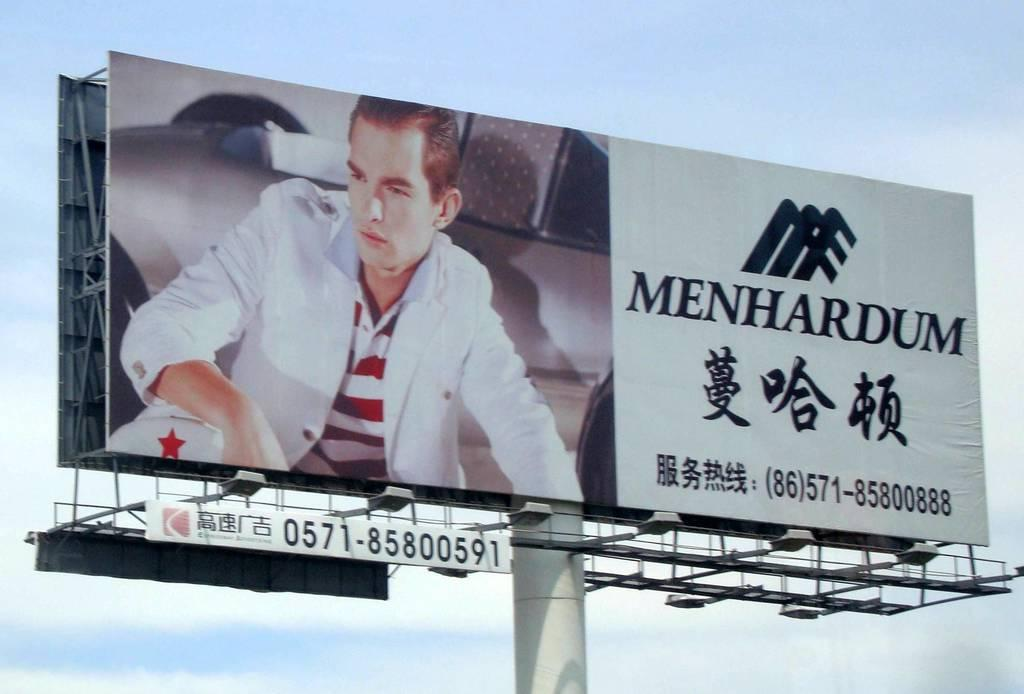Provide a one-sentence caption for the provided image. A young man is dressed in a nice, casual suit, on a billboard for Menhardum. 